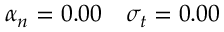<formula> <loc_0><loc_0><loc_500><loc_500>\alpha _ { n } = 0 . 0 0 \quad \sigma _ { t } = 0 . 0 0</formula> 